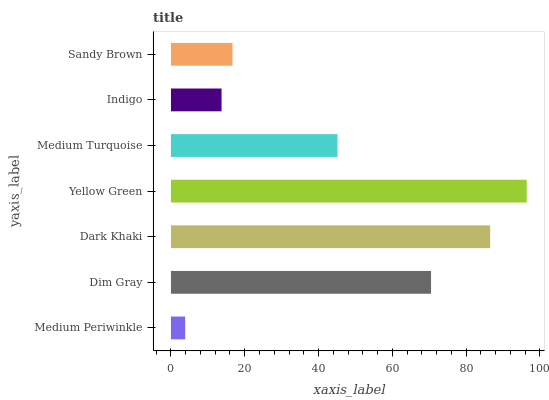Is Medium Periwinkle the minimum?
Answer yes or no. Yes. Is Yellow Green the maximum?
Answer yes or no. Yes. Is Dim Gray the minimum?
Answer yes or no. No. Is Dim Gray the maximum?
Answer yes or no. No. Is Dim Gray greater than Medium Periwinkle?
Answer yes or no. Yes. Is Medium Periwinkle less than Dim Gray?
Answer yes or no. Yes. Is Medium Periwinkle greater than Dim Gray?
Answer yes or no. No. Is Dim Gray less than Medium Periwinkle?
Answer yes or no. No. Is Medium Turquoise the high median?
Answer yes or no. Yes. Is Medium Turquoise the low median?
Answer yes or no. Yes. Is Medium Periwinkle the high median?
Answer yes or no. No. Is Indigo the low median?
Answer yes or no. No. 